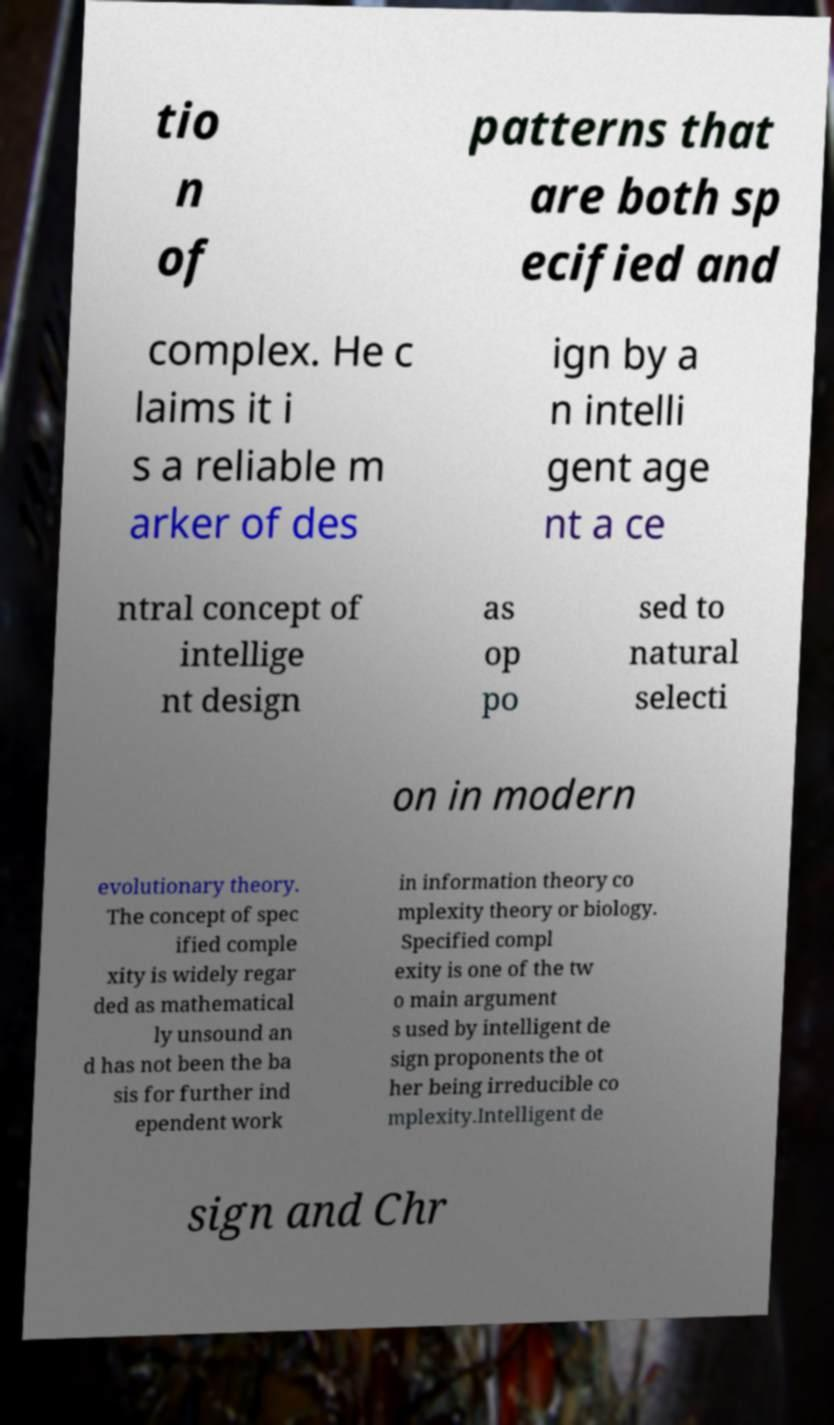Please read and relay the text visible in this image. What does it say? tio n of patterns that are both sp ecified and complex. He c laims it i s a reliable m arker of des ign by a n intelli gent age nt a ce ntral concept of intellige nt design as op po sed to natural selecti on in modern evolutionary theory. The concept of spec ified comple xity is widely regar ded as mathematical ly unsound an d has not been the ba sis for further ind ependent work in information theory co mplexity theory or biology. Specified compl exity is one of the tw o main argument s used by intelligent de sign proponents the ot her being irreducible co mplexity.Intelligent de sign and Chr 